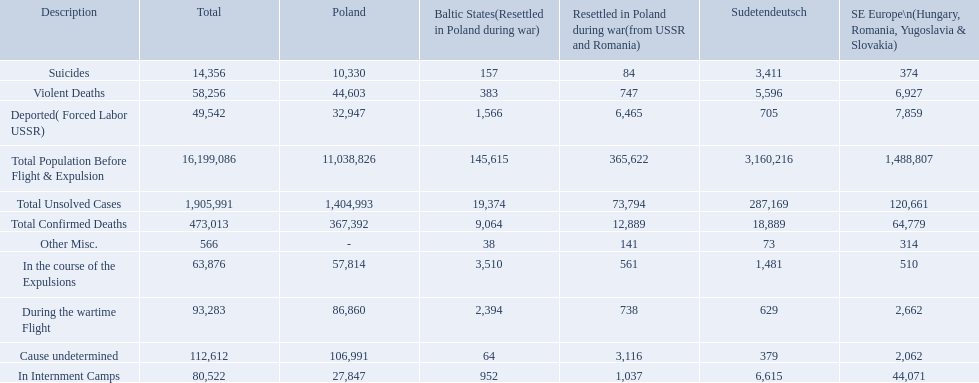What are all of the descriptions? Total Population Before Flight & Expulsion, Violent Deaths, Suicides, Deported( Forced Labor USSR), In Internment Camps, During the wartime Flight, In the course of the Expulsions, Cause undetermined, Other Misc., Total Confirmed Deaths, Total Unsolved Cases. What were their total number of deaths? 16,199,086, 58,256, 14,356, 49,542, 80,522, 93,283, 63,876, 112,612, 566, 473,013, 1,905,991. What about just from violent deaths? 58,256. Can you give me this table as a dict? {'header': ['Description', 'Total', 'Poland', 'Baltic States(Resettled in Poland during war)', 'Resettled in Poland during war(from USSR and Romania)', 'Sudetendeutsch', 'SE Europe\\n(Hungary, Romania, Yugoslavia & Slovakia)'], 'rows': [['Suicides', '14,356', '10,330', '157', '84', '3,411', '374'], ['Violent Deaths', '58,256', '44,603', '383', '747', '5,596', '6,927'], ['Deported( Forced Labor USSR)', '49,542', '32,947', '1,566', '6,465', '705', '7,859'], ['Total Population Before Flight & Expulsion', '16,199,086', '11,038,826', '145,615', '365,622', '3,160,216', '1,488,807'], ['Total Unsolved Cases', '1,905,991', '1,404,993', '19,374', '73,794', '287,169', '120,661'], ['Total Confirmed Deaths', '473,013', '367,392', '9,064', '12,889', '18,889', '64,779'], ['Other Misc.', '566', '-', '38', '141', '73', '314'], ['In the course of the Expulsions', '63,876', '57,814', '3,510', '561', '1,481', '510'], ['During the wartime Flight', '93,283', '86,860', '2,394', '738', '629', '2,662'], ['Cause undetermined', '112,612', '106,991', '64', '3,116', '379', '2,062'], ['In Internment Camps', '80,522', '27,847', '952', '1,037', '6,615', '44,071']]} What are the numbers of violent deaths across the area? 44,603, 383, 747, 5,596, 6,927. What is the total number of violent deaths of the area? 58,256. How many deaths did the baltic states have in each category? 145,615, 383, 157, 1,566, 952, 2,394, 3,510, 64, 38, 9,064, 19,374. How many cause undetermined deaths did baltic states have? 64. How many other miscellaneous deaths did baltic states have? 38. Which is higher in deaths, cause undetermined or other miscellaneous? Cause undetermined. 